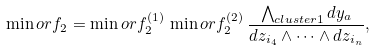Convert formula to latex. <formula><loc_0><loc_0><loc_500><loc_500>\min o r f _ { 2 } = \min o r f _ { 2 } ^ { ( 1 ) } \, \min o r f _ { 2 } ^ { ( 2 ) } \, \frac { \bigwedge _ { c l u s t e r 1 } d y _ { a } } { d z _ { i _ { 4 } } \wedge \dots \wedge d z _ { i _ { n } } } ,</formula> 